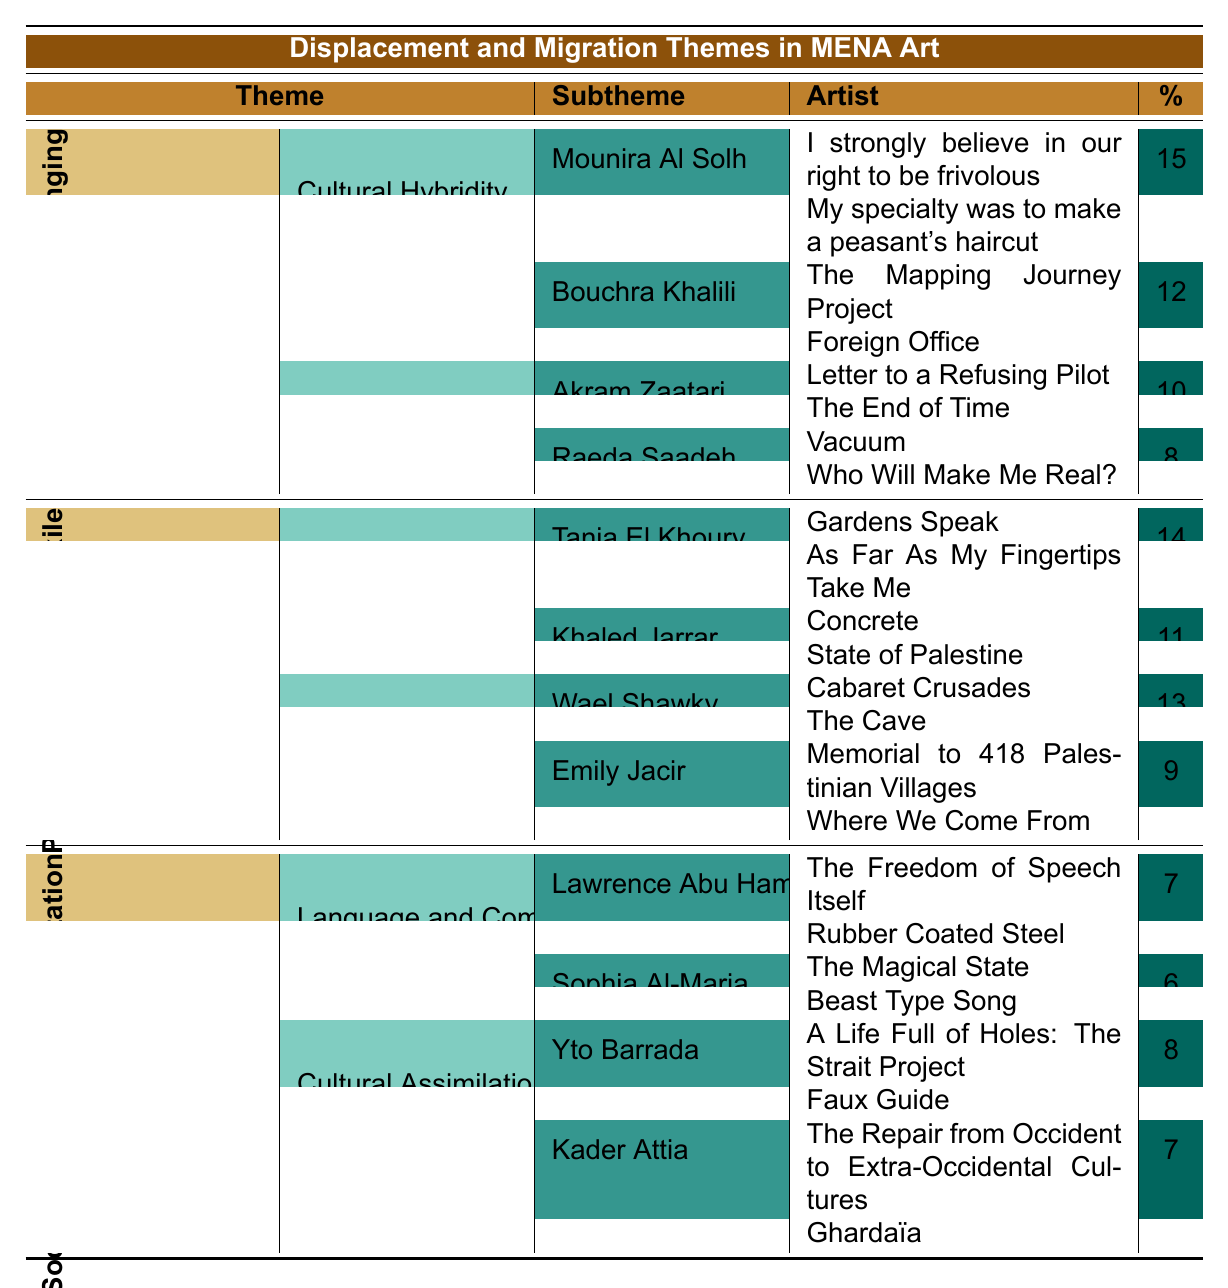What is the percentage of Mounira Al Solh's artworks in the theme "Identity and Belonging"? Mounira Al Solh has two artworks listed under the "Cultural Hybridity" subtheme within the "Identity and Belonging" theme, with a percentage of 15.
Answer: 15 Which artist contributed to the "Border Crossings" subtheme? Tania El Khoury and Khaled Jarrar are the artists listed under the "Border Crossings" subtheme, with their corresponding artworks specified.
Answer: Tania El Khoury and Khaled Jarrar How many artworks does Wael Shawky have in total in the table? Wael Shawky has two artworks listed under the "Displacement Narratives" subtheme, the artworks are "Cabaret Crusades" and "The Cave".
Answer: 2 Which theme has the highest percentage of artworks related to displacement and migration? The theme "Political Conflict and Exile" includes subthemes with high percentages (Border Crossings 14% and Displacement Narratives 13%), giving it a higher total percentage than the others.
Answer: Political Conflict and Exile What is the sum of percentages for artists under the "Cultural Hybridity" subtheme? The percentages for the artists under "Cultural Hybridity" are Mounira Al Solh (15%) and Bouchra Khalili (12%). Summing these gives 15 + 12 = 27.
Answer: 27 Is Emily Jacir involved in the "Cultural Assimilation" subtheme? No, Emily Jacir's artworks are listed under the "Displacement Narratives" subtheme, not "Cultural Assimilation".
Answer: No What percentage represents the total contributions of artists under "Language and Communication"? Lawrence Abu Hamdan has a percentage of 7 and Sophia Al-Maria has 6. Their total contributions are 7 + 6 = 13.
Answer: 13 Which artist has the lowest percentage in the table? Sophia Al-Maria contributes the least with a percentage of 6, making her the artist with the lowest percentage.
Answer: Sophia Al-Maria How many subthemes are represented under the theme "Social Integration and Adaptation"? There are two subthemes under "Social Integration and Adaptation": "Language and Communication" and "Cultural Assimilation".
Answer: 2 Which artist contributed the most artworks? Mounira Al Solh, with two artworks, is tied for the most contributions. However, both Yto Barrada and others also have limited contributions.
Answer: Mounira Al Solh and others 